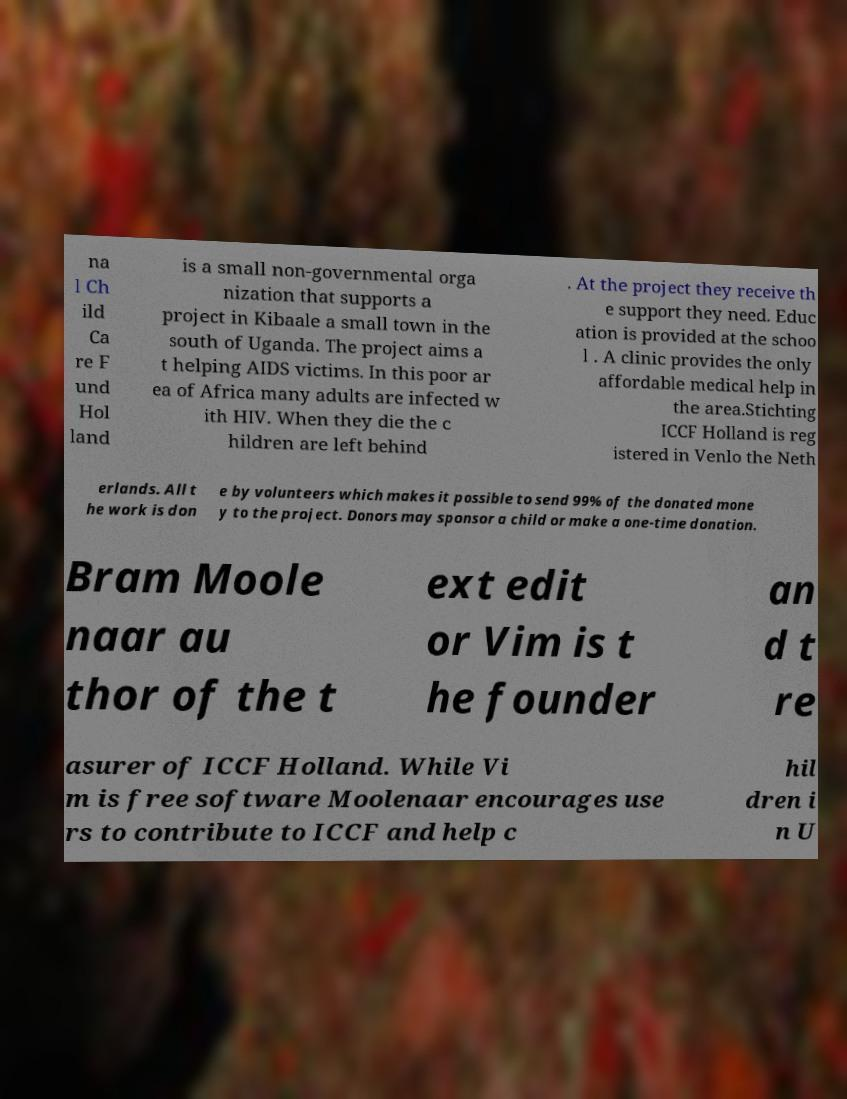I need the written content from this picture converted into text. Can you do that? na l Ch ild Ca re F und Hol land is a small non-governmental orga nization that supports a project in Kibaale a small town in the south of Uganda. The project aims a t helping AIDS victims. In this poor ar ea of Africa many adults are infected w ith HIV. When they die the c hildren are left behind . At the project they receive th e support they need. Educ ation is provided at the schoo l . A clinic provides the only affordable medical help in the area.Stichting ICCF Holland is reg istered in Venlo the Neth erlands. All t he work is don e by volunteers which makes it possible to send 99% of the donated mone y to the project. Donors may sponsor a child or make a one-time donation. Bram Moole naar au thor of the t ext edit or Vim is t he founder an d t re asurer of ICCF Holland. While Vi m is free software Moolenaar encourages use rs to contribute to ICCF and help c hil dren i n U 